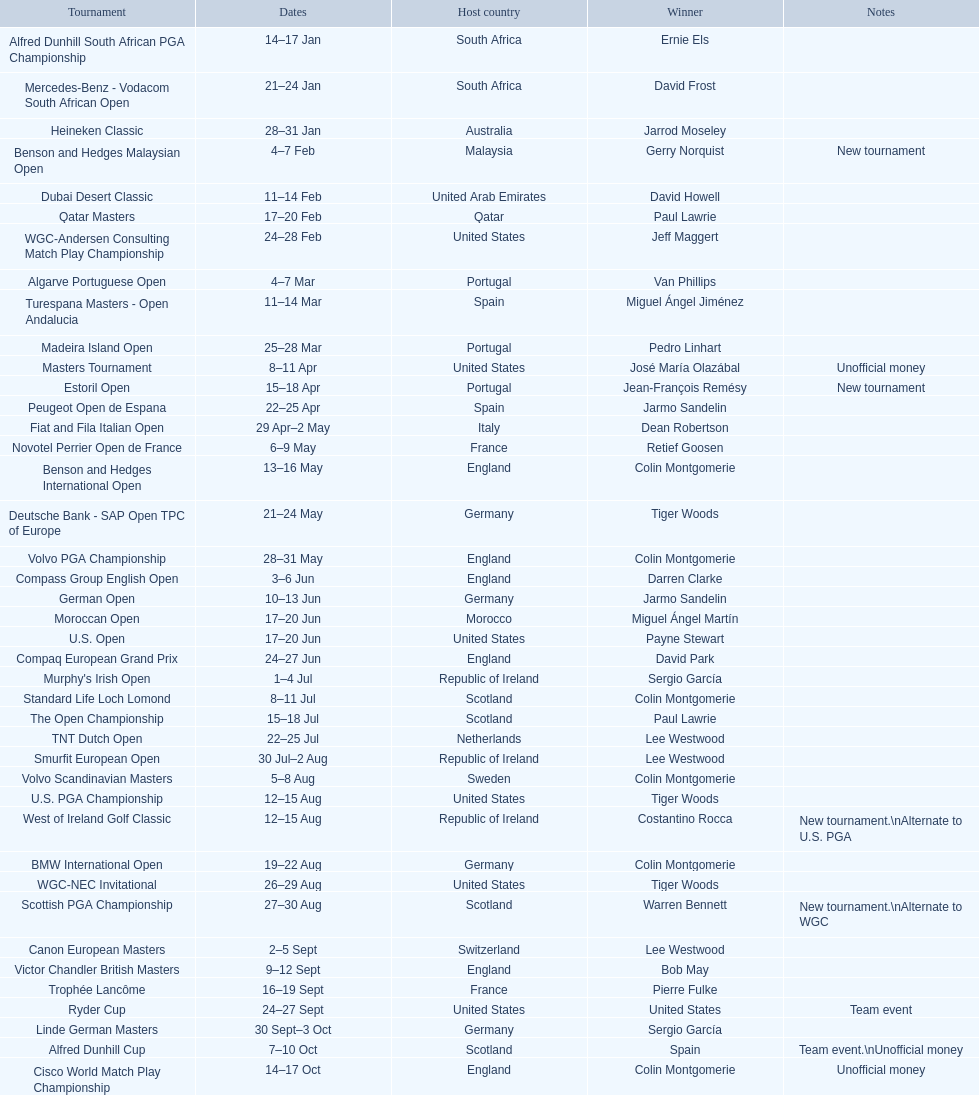How many tournaments began before aug 15th 31. 